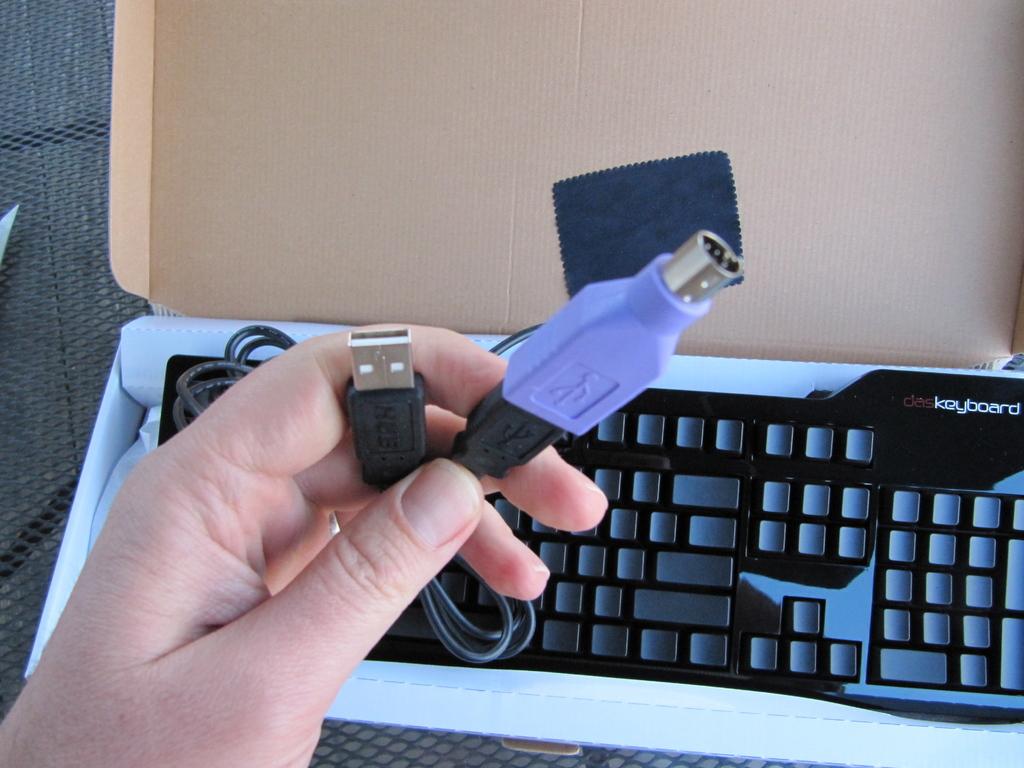Is that a keyboard?
Ensure brevity in your answer.  Yes. What brand of keyboard?
Offer a terse response. Daskeyboard. 